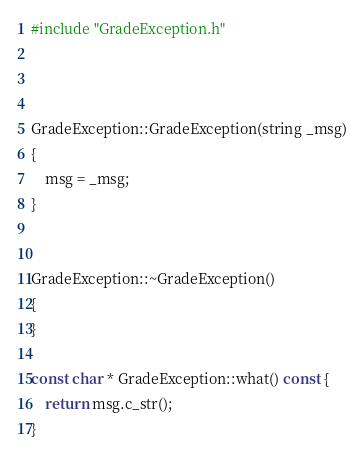<code> <loc_0><loc_0><loc_500><loc_500><_C++_>#include "GradeException.h"



GradeException::GradeException(string _msg)
{
	msg = _msg;
}


GradeException::~GradeException()
{
}

const char * GradeException::what() const {
	return msg.c_str();
}
</code> 